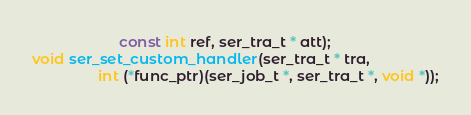<code> <loc_0><loc_0><loc_500><loc_500><_C_>				     const int ref, ser_tra_t * att);
void ser_set_custom_handler(ser_tra_t * tra,
			    int (*func_ptr)(ser_job_t *, ser_tra_t *, void *));</code> 